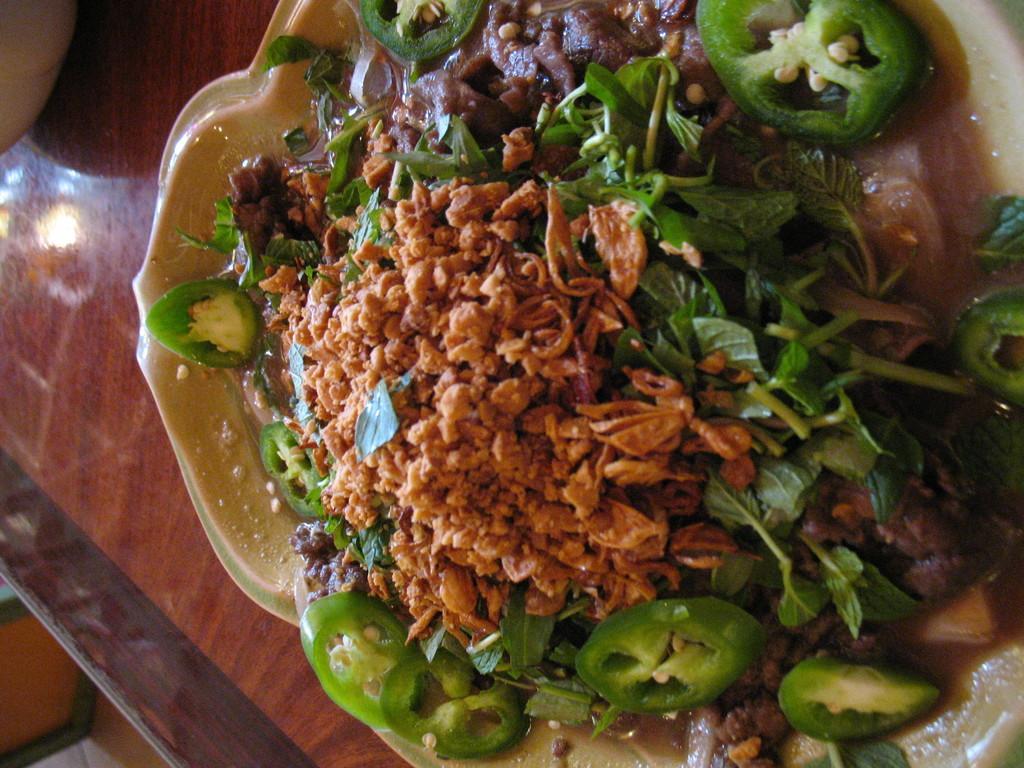In one or two sentences, can you explain what this image depicts? In this image I can see a food in the plate. Food is in brown and green color. Food is on the brown table. 